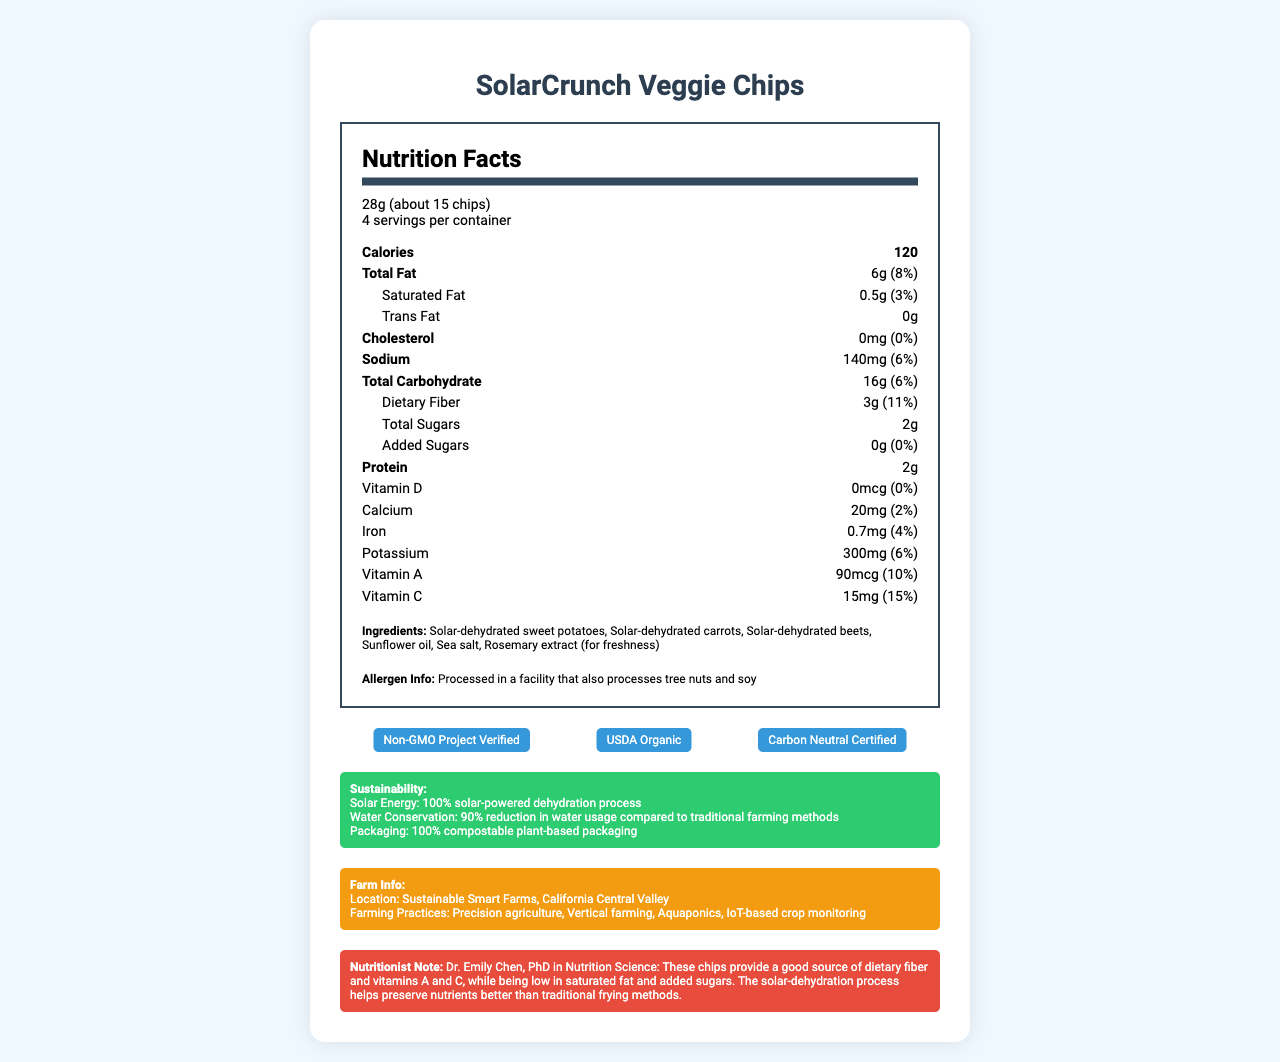what is the serving size of SolarCrunch Veggie Chips? The serving size is clearly listed under "serving size" as "28g (about 15 chips)".
Answer: 28g (about 15 chips) how many servings are in each container of SolarCrunch Veggie Chips? The document specifies that there are 4 servings per container.
Answer: 4 servings how many calories are in one serving of SolarCrunch Veggie Chips? The document lists the calories per serving as 120.
Answer: 120 calories What percentage of the daily value of vitamin C is provided per serving? This information is found under the nutritional values for vitamins, where vitamin C is listed with a 15% daily value.
Answer: 15% what is the total fat content per serving and its daily value percentage? The total fat content and its daily value percentage are listed as 6g and 8%, respectively.
Answer: 6g, 8% which vitamins are present in SolarCrunch Veggie Chips? A. Vitamin A B. Vitamin B C. Vitamin C D. Vitamin D The document lists vitamins A, C, and D under the nutritional information section.
Answer: A, C, and D what is the source of freshness mentioned in the ingredients? The ingredients list includes "Rosemary extract (for freshness)".
Answer: Rosemary extract SolarCrunch Veggie Chips are certified by which organizations? A. Non-GMO Project Verified B. USDA Organic C. Carbon Neutral Certified D. Fair Trade Certified The certifications section lists "Non-GMO Project Verified", "USDA Organic", and "Carbon Neutral Certified".
Answer: A, B, and C are these chips gluten-free? The document does not specify if the chips are gluten-free.
Answer: Not enough information is any cholesterol present in SolarCrunch Veggie Chips? The nutritional information lists cholesterol as 0mg, indicating no cholesterol.
Answer: No describe the farming practices used to produce SolarCrunch Veggie Chips. The farm info section lists these sustainable farming practices.
Answer: Precision agriculture, Vertical farming, Aquaponics, IoT-based crop monitoring is the packaging material for SolarCrunch Veggie Chips eco-friendly? The packaging material is stated to be "100% compostable plant-based packaging".
Answer: Yes which cooking method helps to preserve the nutrients in SolarCrunch Veggie Chips better than traditional frying methods? Dr. Emily Chen notes that the solar-dehydration process preserves nutrients better.
Answer: Solar-dehydration process can we determine the availability date of SolarCrunch Veggie Chips from the document? The document does not contain any information about the availability date of the product.
Answer: Not enough information 